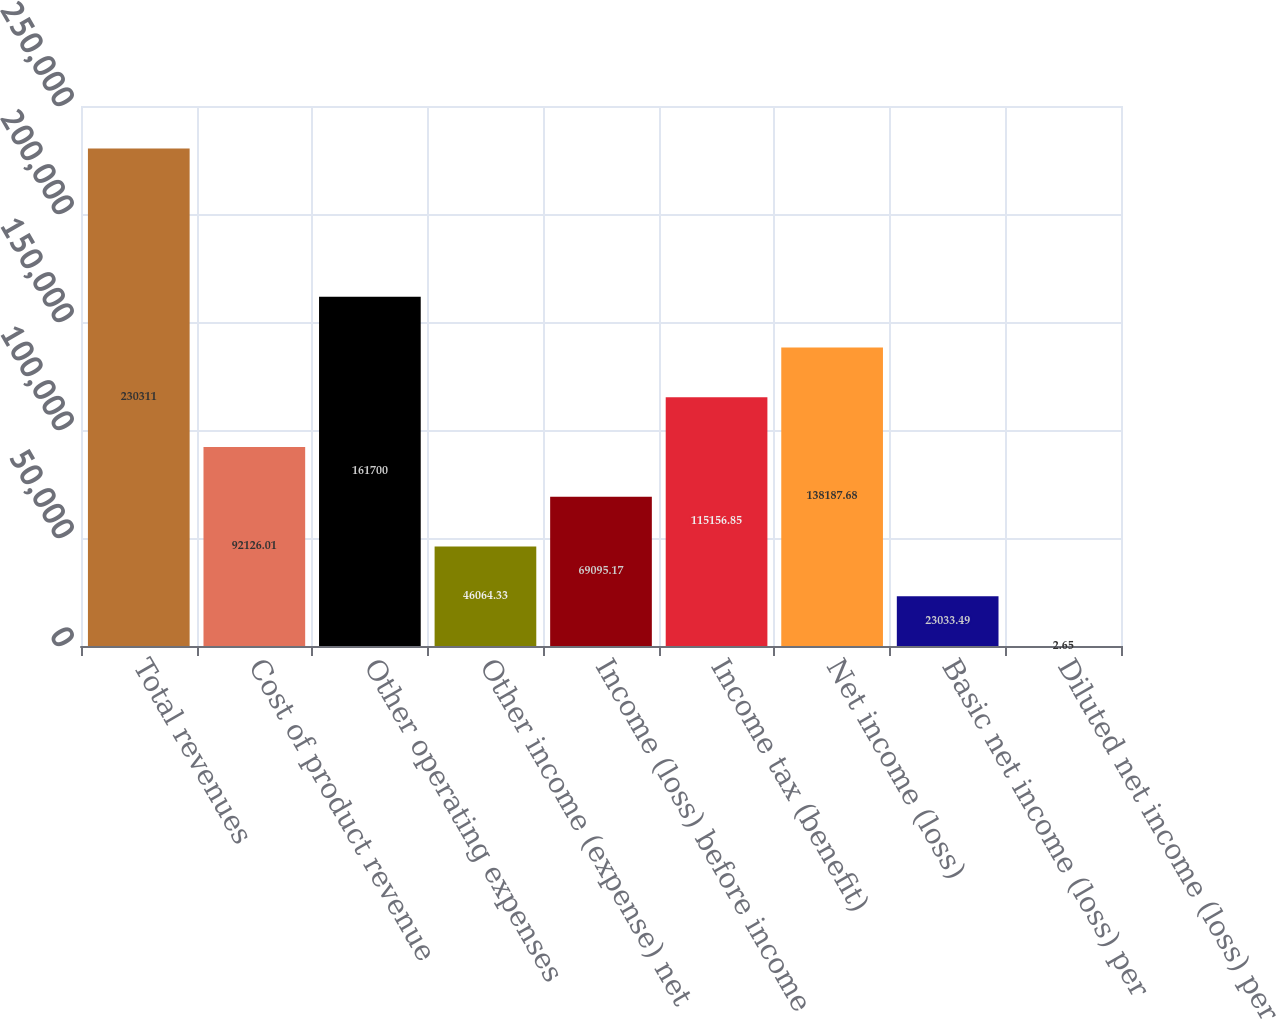<chart> <loc_0><loc_0><loc_500><loc_500><bar_chart><fcel>Total revenues<fcel>Cost of product revenue<fcel>Other operating expenses<fcel>Other income (expense) net<fcel>Income (loss) before income<fcel>Income tax (benefit)<fcel>Net income (loss)<fcel>Basic net income (loss) per<fcel>Diluted net income (loss) per<nl><fcel>230311<fcel>92126<fcel>161700<fcel>46064.3<fcel>69095.2<fcel>115157<fcel>138188<fcel>23033.5<fcel>2.65<nl></chart> 